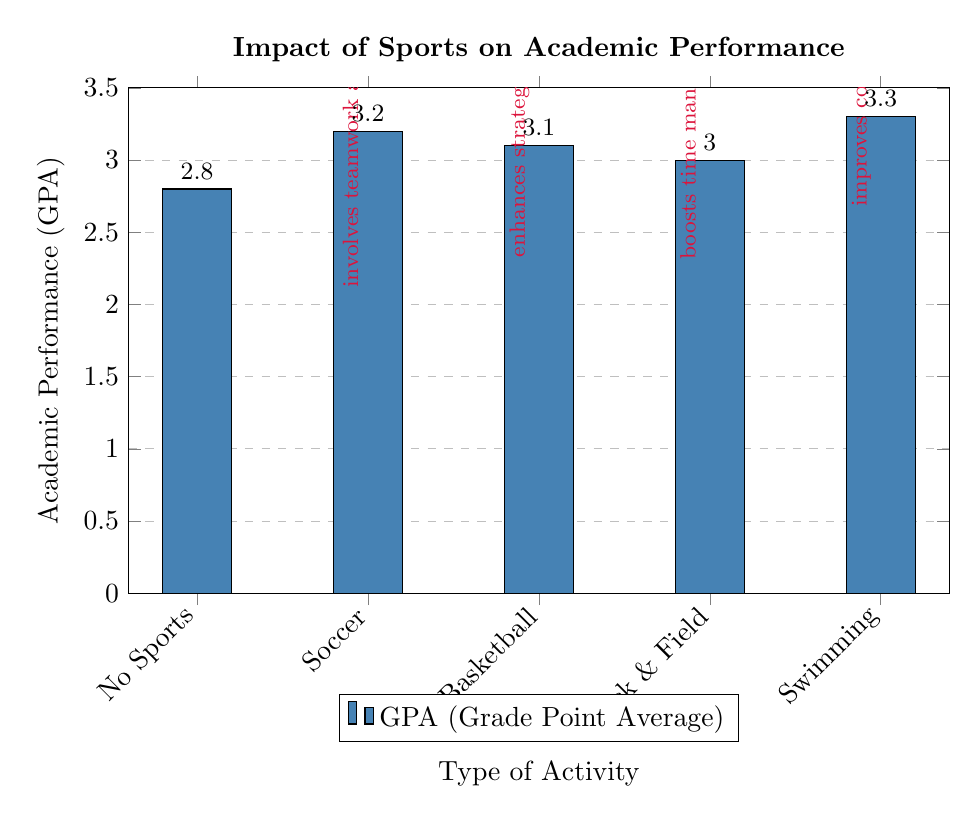What is the GPA for students who do not participate in sports? The diagram shows the bar labeled "No Sports," which has a value of 2.8 for GPA.
Answer: 2.8 Which sport has the highest GPA according to the diagram? By comparing the bars, "Swimming" has the highest GPA value at 3.3.
Answer: Swimming What is the GPA for Soccer participants? The value for the "Soccer" bar indicates a GPA of 3.2.
Answer: 3.2 How many sports types are compared in the diagram? The diagram lists five types of activities: No Sports, Soccer, Basketball, Track & Field, and Swimming. Therefore, there are five sports types.
Answer: 5 What annotation is associated with Track & Field? The annotation next to the "Track & Field" bar states that it "boosts time management."
Answer: boosts time management Which has a higher GPA, Basketball or Track & Field? Comparing the two bars, Basketball has a GPA of 3.1 while Track & Field has a GPA of 3.0; thus, Basketball has the higher GPA.
Answer: Basketball What does the diagram suggest about the overall impact of sports on academic performance? The note in the diagram states that participating in sports generally enhances academic performance due to improved discipline, time management, and cognitive skills, indicating a positive impact.
Answer: enhances academic performance What is the GPA for Swimming participants? The diagram shows the "Swimming" bar has a GPA of 3.3.
Answer: 3.3 What color is used for the bars in this diagram? The bars are filled with a color defined as "barcolor," which is described in the diagram as RGB(70,130,180).
Answer: barcolor 